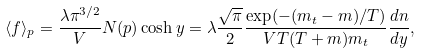Convert formula to latex. <formula><loc_0><loc_0><loc_500><loc_500>\langle f \rangle _ { p } = \frac { \lambda \pi ^ { 3 / 2 } } { V } N ( { p } ) \cosh y = \lambda \frac { \sqrt { \pi } } { 2 } \frac { \exp ( - ( m _ { t } - m ) / T ) } { V T ( T + m ) m _ { t } } \frac { d n } { d y } ,</formula> 